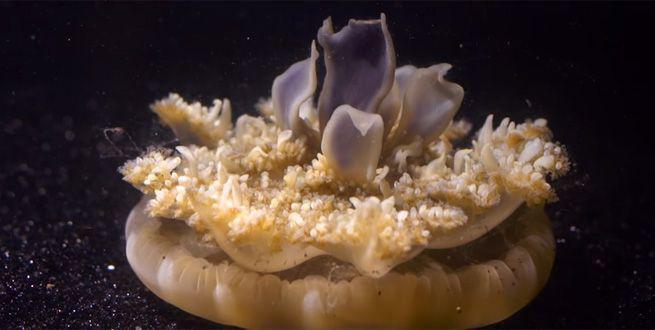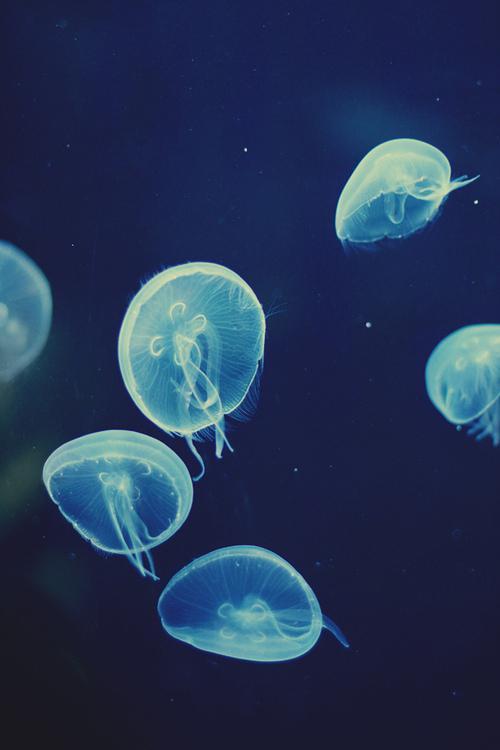The first image is the image on the left, the second image is the image on the right. For the images shown, is this caption "Exactly one creature is sitting on the bottom." true? Answer yes or no. Yes. The first image is the image on the left, the second image is the image on the right. Assess this claim about the two images: "The jellyfish in the left and right images share the same shape 'caps' and are positioned with their tentacles facing the same direction.". Correct or not? Answer yes or no. No. 